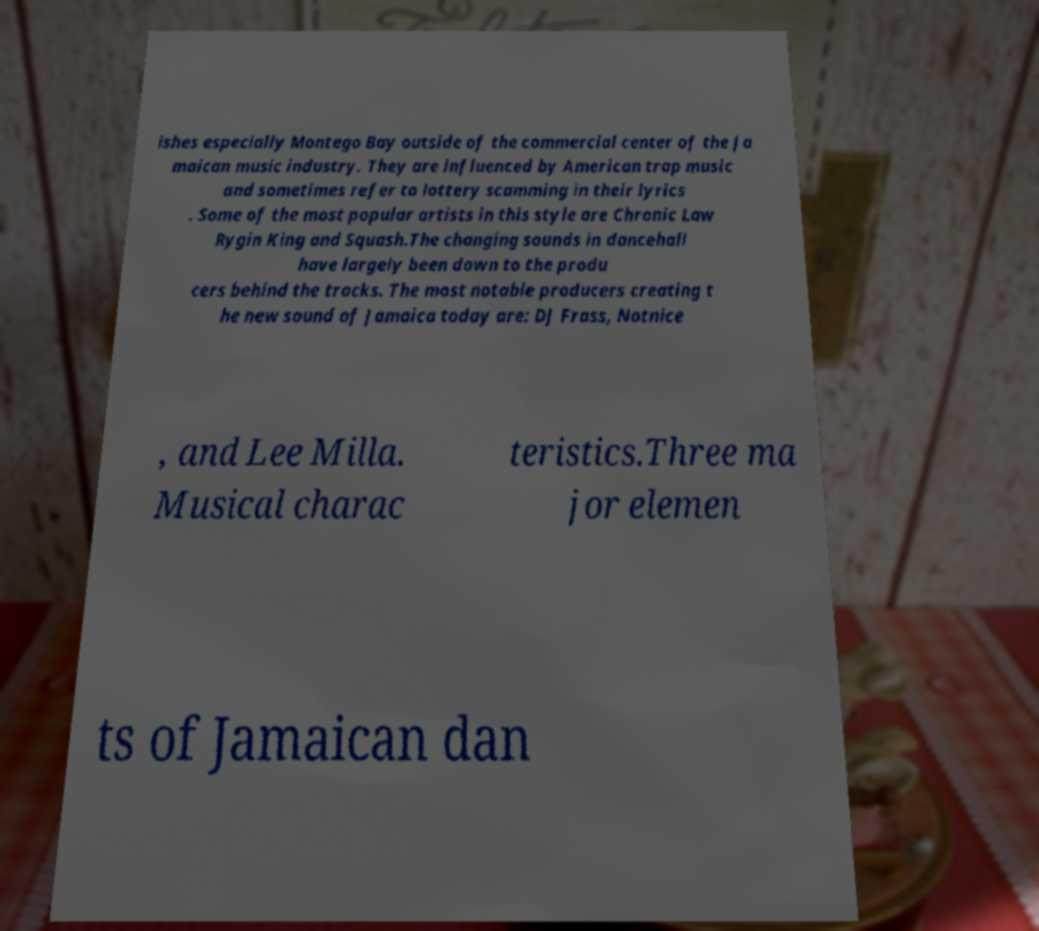What messages or text are displayed in this image? I need them in a readable, typed format. ishes especially Montego Bay outside of the commercial center of the Ja maican music industry. They are influenced by American trap music and sometimes refer to lottery scamming in their lyrics . Some of the most popular artists in this style are Chronic Law Rygin King and Squash.The changing sounds in dancehall have largely been down to the produ cers behind the tracks. The most notable producers creating t he new sound of Jamaica today are: DJ Frass, Notnice , and Lee Milla. Musical charac teristics.Three ma jor elemen ts of Jamaican dan 